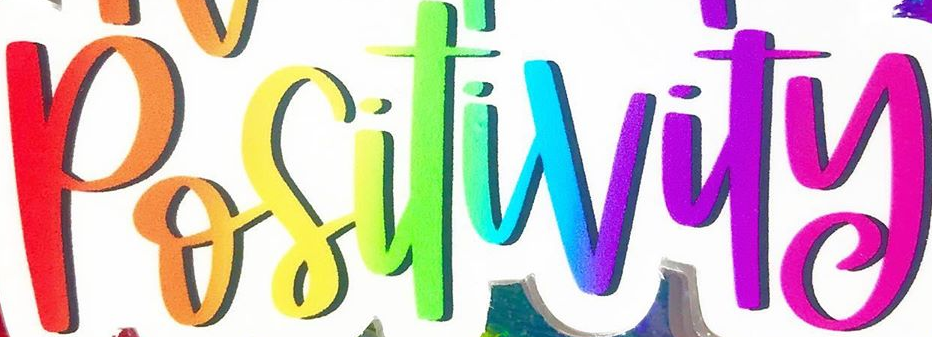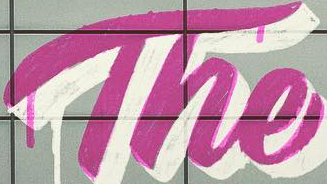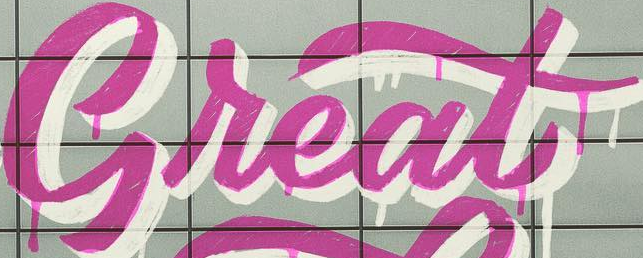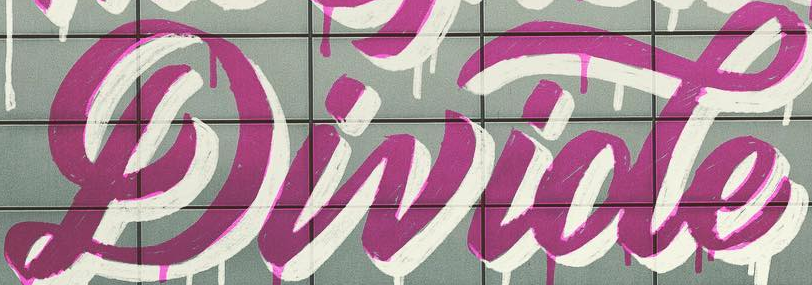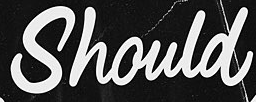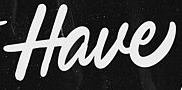Identify the words shown in these images in order, separated by a semicolon. Positivity; The; Great; Divide; Should; Have 